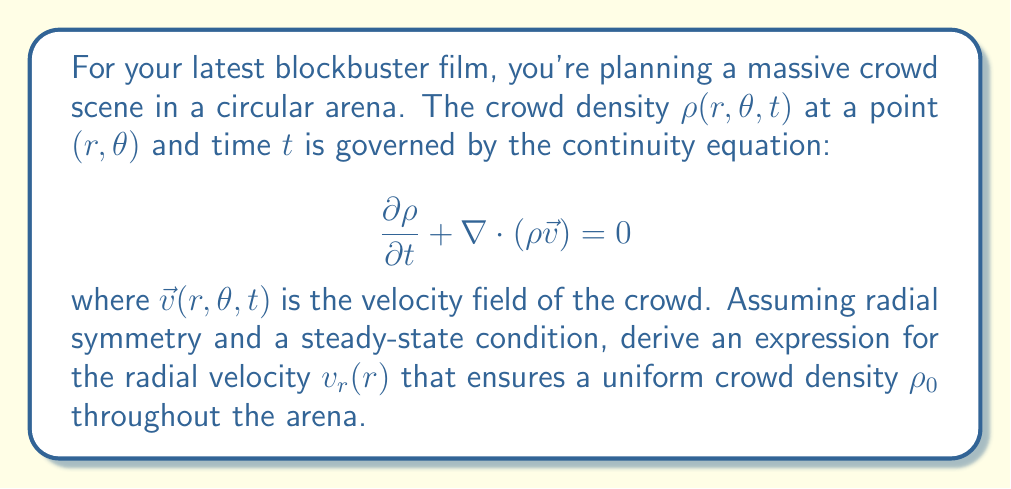What is the answer to this math problem? Let's approach this step-by-step:

1) Given the radial symmetry and steady-state condition, we can simplify the continuity equation. The time derivative becomes zero, and there's no dependence on $\theta$:

   $$\nabla \cdot (\rho \vec{v}) = 0$$

2) In polar coordinates, the divergence operator is:

   $$\nabla \cdot (\rho \vec{v}) = \frac{1}{r}\frac{\partial}{\partial r}(r\rho v_r) + \frac{1}{r}\frac{\partial}{\partial \theta}(\rho v_\theta)$$

3) With radial symmetry, $v_\theta = 0$ and there's no $\theta$ dependence, so:

   $$\frac{1}{r}\frac{\partial}{\partial r}(r\rho v_r) = 0$$

4) We want a uniform density $\rho_0$, so $\rho$ is constant. We can take it out of the derivative:

   $$\frac{1}{r}\frac{\partial}{\partial r}(rv_r) = 0$$

5) Integrating both sides with respect to $r$:

   $$rv_r = C$$

   where $C$ is a constant of integration.

6) Solving for $v_r$:

   $$v_r(r) = \frac{C}{r}$$

This expression for $v_r(r)$ ensures that the crowd density remains uniform throughout the arena.
Answer: The radial velocity that ensures a uniform crowd density is:

$$v_r(r) = \frac{C}{r}$$

where $C$ is a constant and $r$ is the radial distance from the center of the arena. 